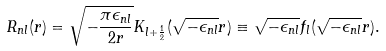<formula> <loc_0><loc_0><loc_500><loc_500>R _ { n l } ( r ) = \sqrt { - \frac { \pi \epsilon _ { n l } } { 2 r } } K _ { l + \frac { 1 } { 2 } } ( \sqrt { - \epsilon _ { n l } } r ) \equiv \sqrt { - \epsilon _ { n l } } f _ { l } ( \sqrt { - \epsilon _ { n l } } r ) .</formula> 